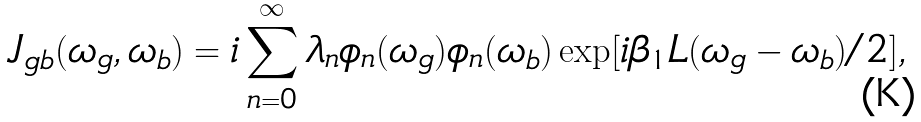Convert formula to latex. <formula><loc_0><loc_0><loc_500><loc_500>J _ { g b } ( \omega _ { g } , \omega _ { b } ) = i \sum _ { n = 0 } ^ { \infty } \lambda _ { n } \phi _ { n } ( \omega _ { g } ) \phi _ { n } ( \omega _ { b } ) \exp [ i \beta _ { 1 } L ( \omega _ { g } - \omega _ { b } ) / 2 ] ,</formula> 